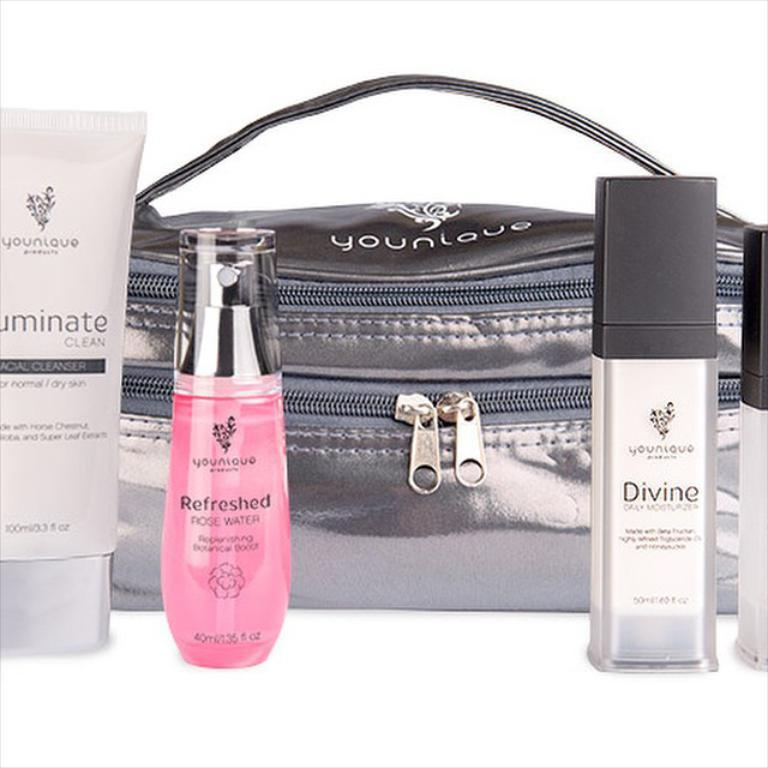<image>
Offer a succinct explanation of the picture presented. Personal care products displayed in front of a purse include small containers of Divine and Refreshed. 